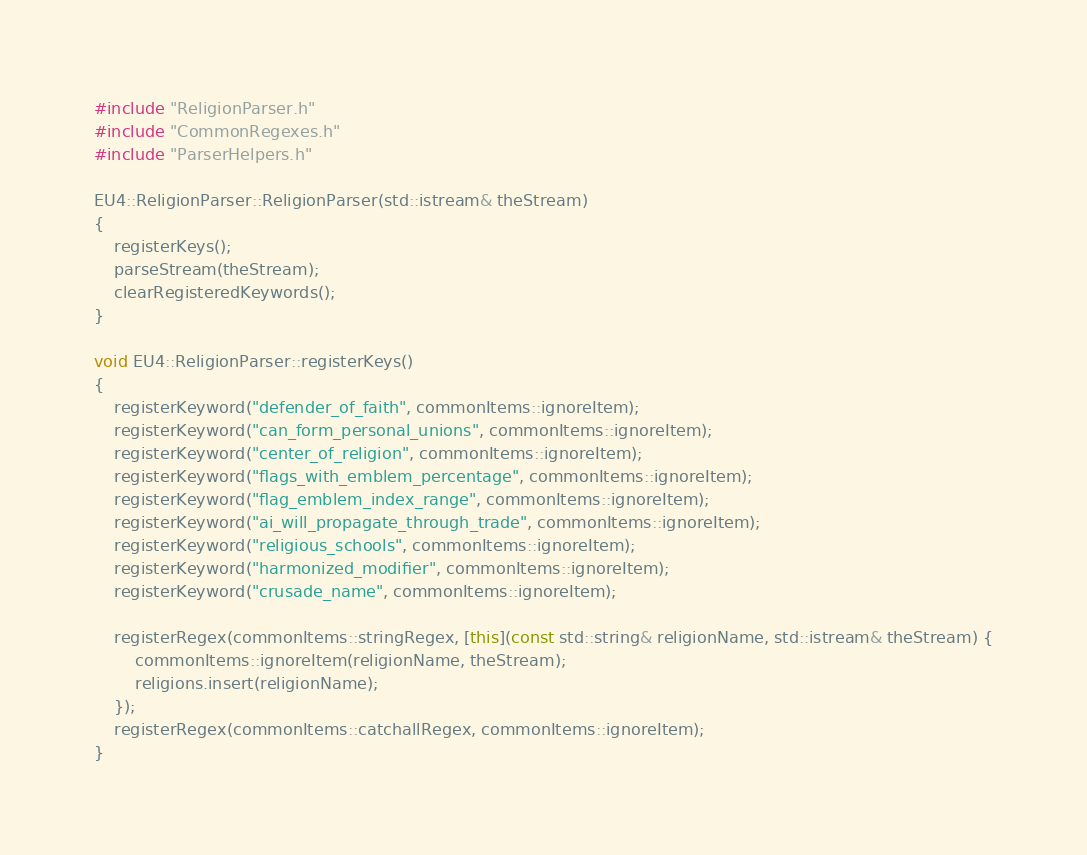<code> <loc_0><loc_0><loc_500><loc_500><_C++_>#include "ReligionParser.h"
#include "CommonRegexes.h"
#include "ParserHelpers.h"

EU4::ReligionParser::ReligionParser(std::istream& theStream)
{
	registerKeys();
	parseStream(theStream);
	clearRegisteredKeywords();
}

void EU4::ReligionParser::registerKeys()
{
	registerKeyword("defender_of_faith", commonItems::ignoreItem);
	registerKeyword("can_form_personal_unions", commonItems::ignoreItem);
	registerKeyword("center_of_religion", commonItems::ignoreItem);
	registerKeyword("flags_with_emblem_percentage", commonItems::ignoreItem);
	registerKeyword("flag_emblem_index_range", commonItems::ignoreItem);
	registerKeyword("ai_will_propagate_through_trade", commonItems::ignoreItem);
	registerKeyword("religious_schools", commonItems::ignoreItem);
	registerKeyword("harmonized_modifier", commonItems::ignoreItem);
	registerKeyword("crusade_name", commonItems::ignoreItem);

	registerRegex(commonItems::stringRegex, [this](const std::string& religionName, std::istream& theStream) {
		commonItems::ignoreItem(religionName, theStream);
		religions.insert(religionName);
	});
	registerRegex(commonItems::catchallRegex, commonItems::ignoreItem);
}
</code> 